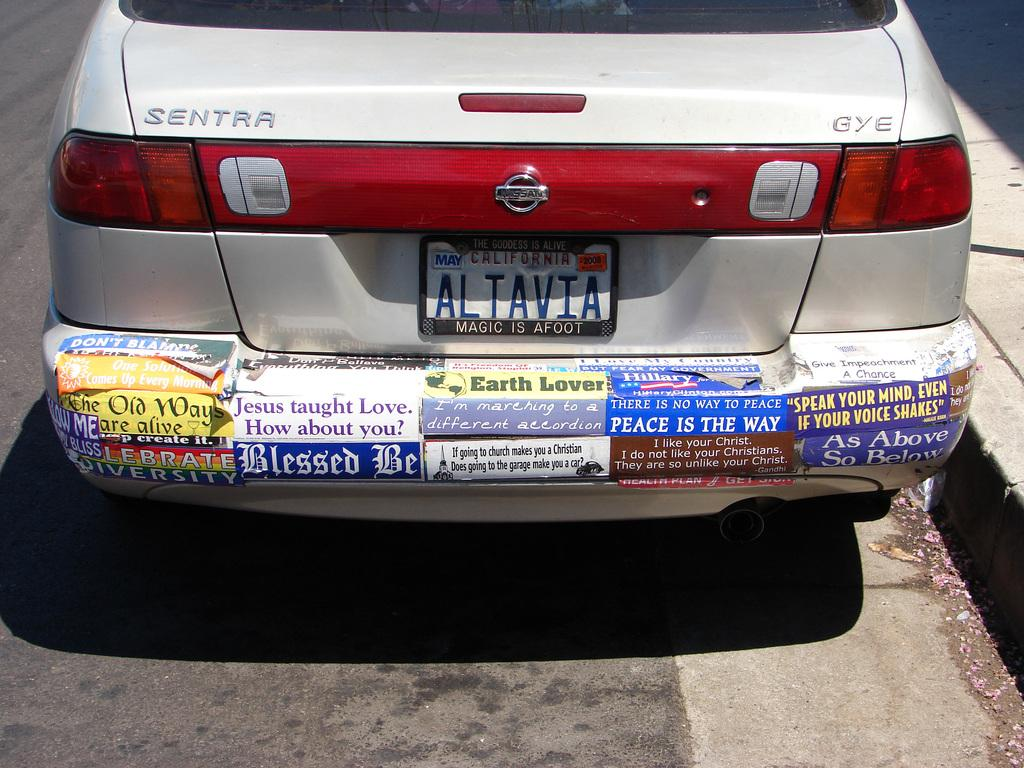What is the main subject of the image? The main subject of the image is a car. Where is the car located in the image? The car is on the road in the image. What other feature can be seen in the image besides the car? There is a footpath in the image. How many spiders are crawling on the car in the image? There are no spiders visible on the car in the image. What type of picture is hanging on the wall in the image? There is no picture hanging on the wall in the image, as it only features a car on the road and a footpath. 